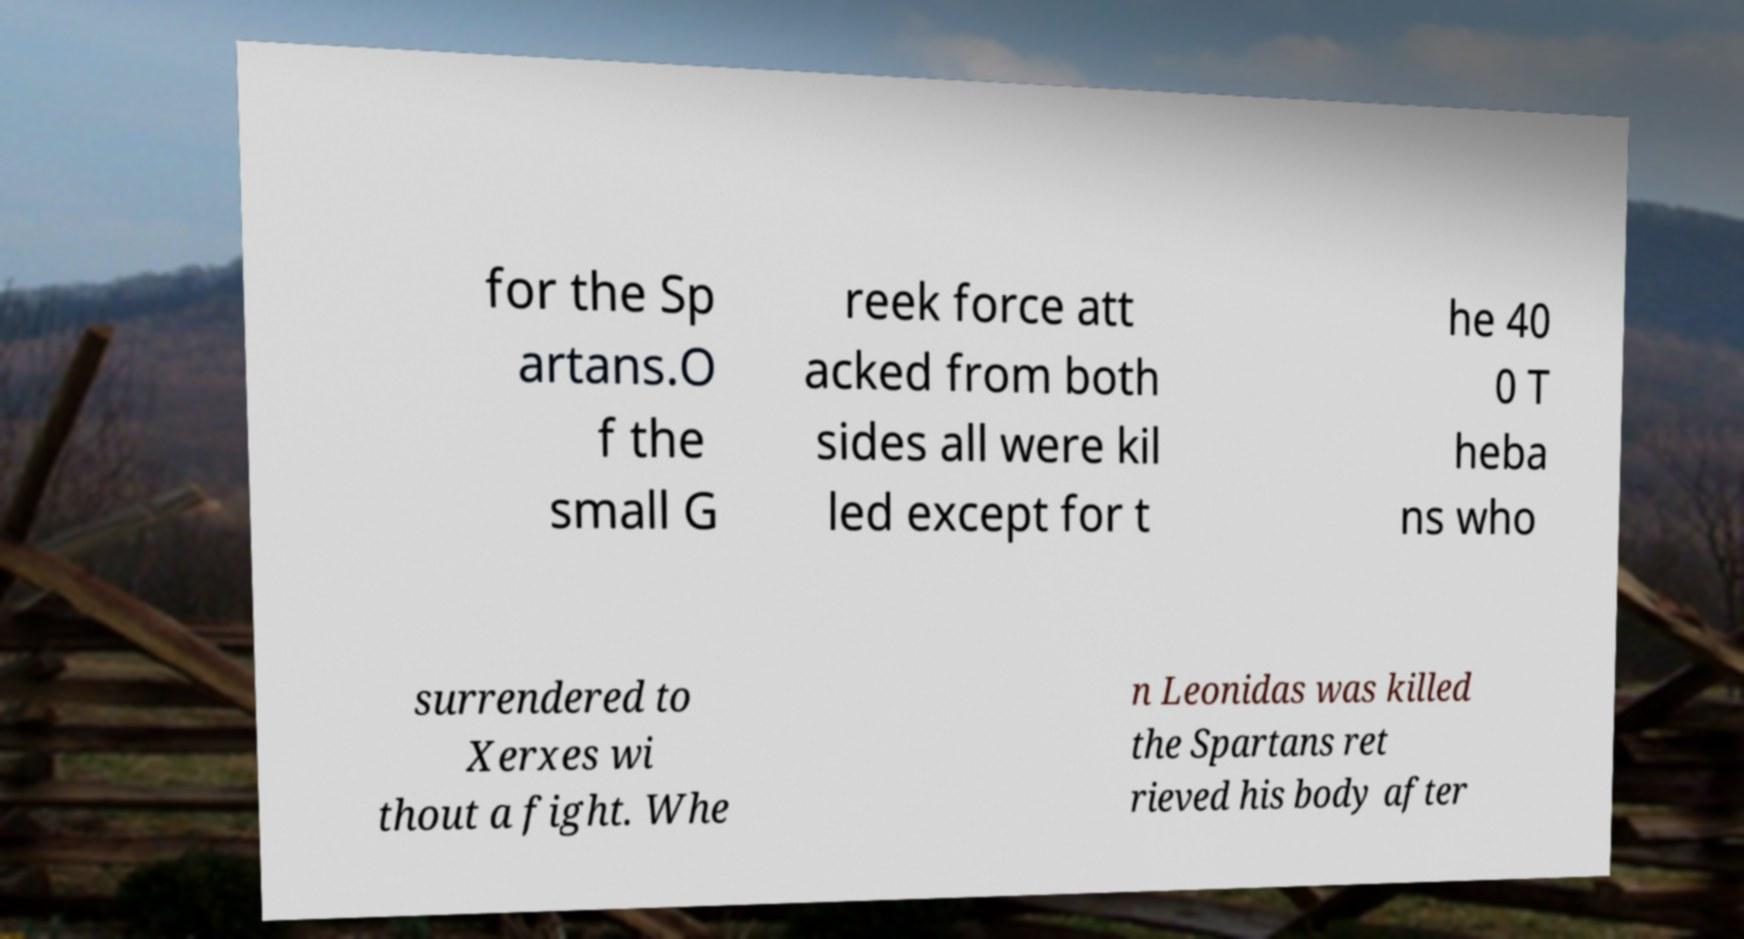Could you extract and type out the text from this image? for the Sp artans.O f the small G reek force att acked from both sides all were kil led except for t he 40 0 T heba ns who surrendered to Xerxes wi thout a fight. Whe n Leonidas was killed the Spartans ret rieved his body after 